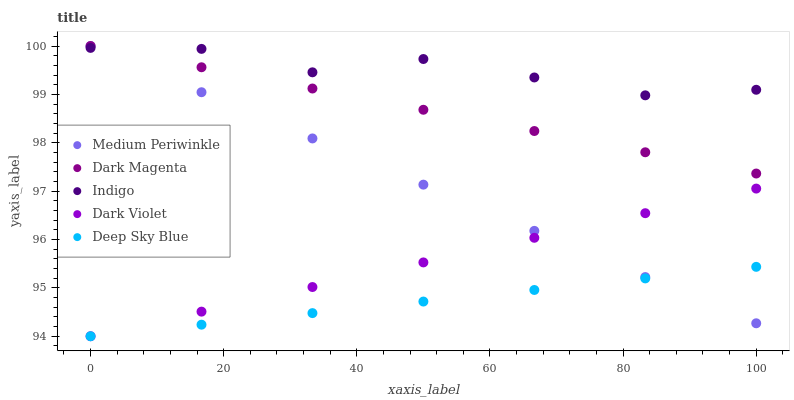Does Deep Sky Blue have the minimum area under the curve?
Answer yes or no. Yes. Does Indigo have the maximum area under the curve?
Answer yes or no. Yes. Does Medium Periwinkle have the minimum area under the curve?
Answer yes or no. No. Does Medium Periwinkle have the maximum area under the curve?
Answer yes or no. No. Is Dark Magenta the smoothest?
Answer yes or no. Yes. Is Indigo the roughest?
Answer yes or no. Yes. Is Medium Periwinkle the smoothest?
Answer yes or no. No. Is Medium Periwinkle the roughest?
Answer yes or no. No. Does Dark Violet have the lowest value?
Answer yes or no. Yes. Does Medium Periwinkle have the lowest value?
Answer yes or no. No. Does Dark Magenta have the highest value?
Answer yes or no. Yes. Does Dark Violet have the highest value?
Answer yes or no. No. Is Dark Violet less than Dark Magenta?
Answer yes or no. Yes. Is Indigo greater than Dark Violet?
Answer yes or no. Yes. Does Medium Periwinkle intersect Dark Violet?
Answer yes or no. Yes. Is Medium Periwinkle less than Dark Violet?
Answer yes or no. No. Is Medium Periwinkle greater than Dark Violet?
Answer yes or no. No. Does Dark Violet intersect Dark Magenta?
Answer yes or no. No. 